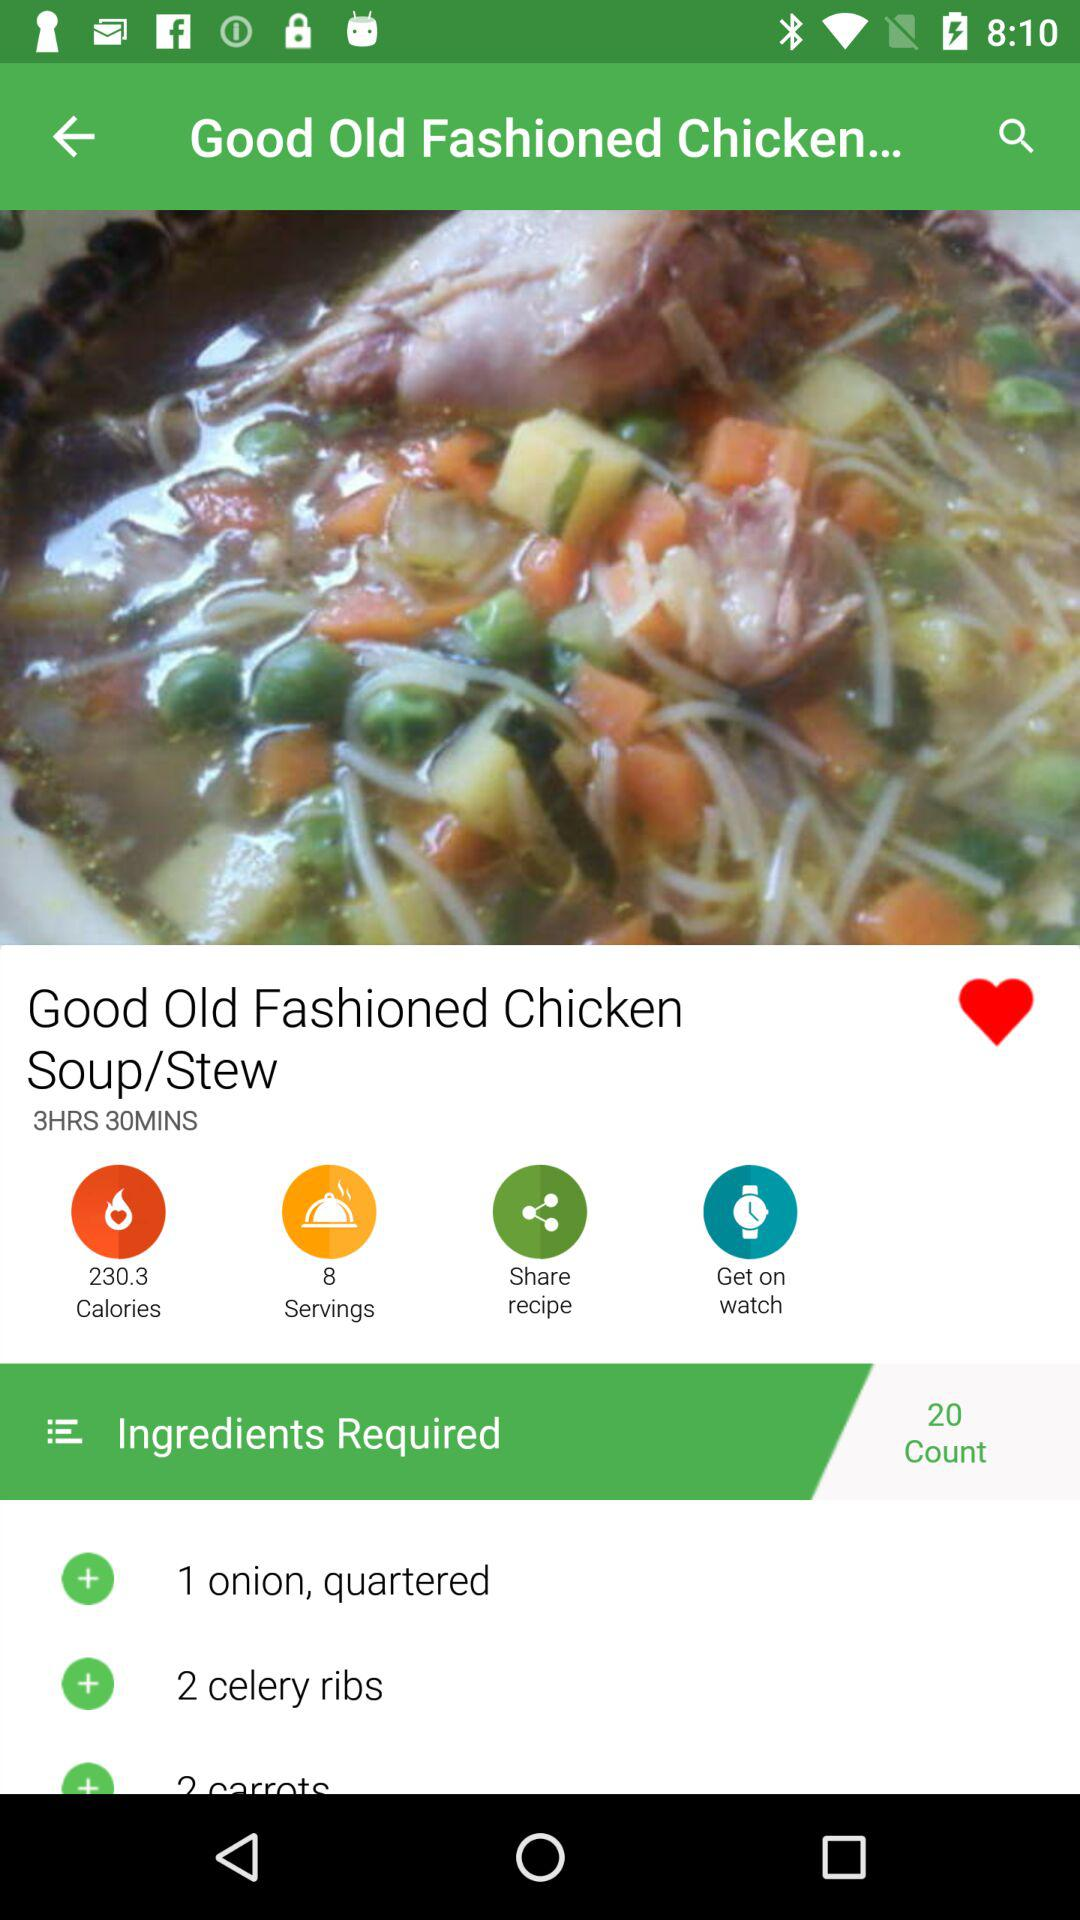How much time will it take to make this dish? The time is 3 hours and 30 minutes. 